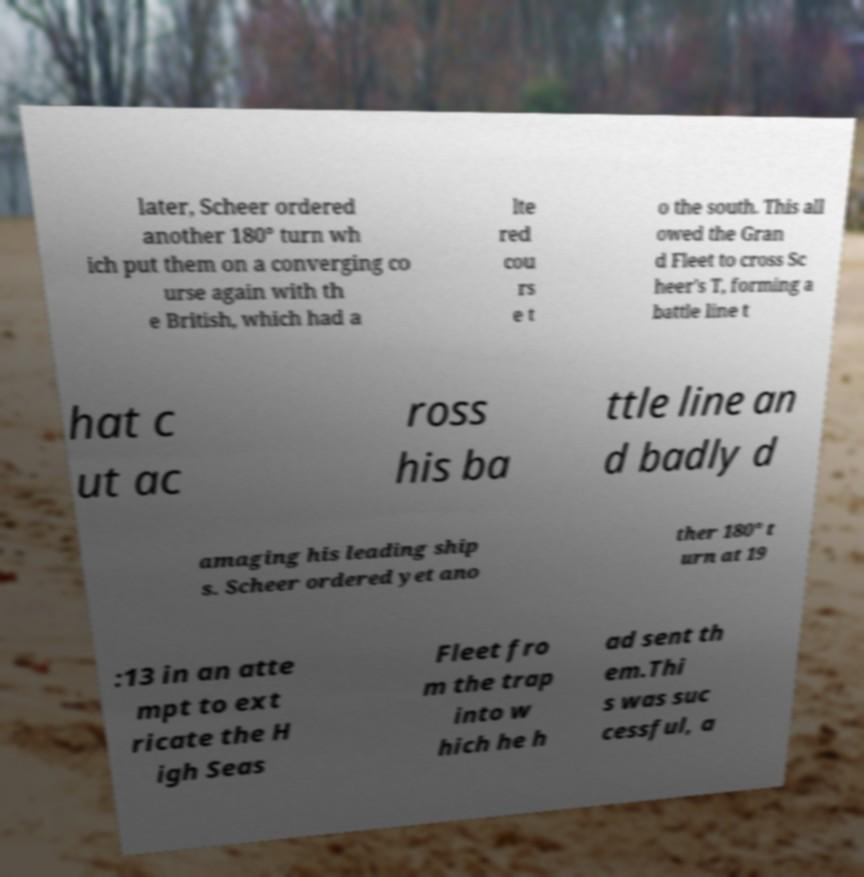Could you assist in decoding the text presented in this image and type it out clearly? later, Scheer ordered another 180° turn wh ich put them on a converging co urse again with th e British, which had a lte red cou rs e t o the south. This all owed the Gran d Fleet to cross Sc heer's T, forming a battle line t hat c ut ac ross his ba ttle line an d badly d amaging his leading ship s. Scheer ordered yet ano ther 180° t urn at 19 :13 in an atte mpt to ext ricate the H igh Seas Fleet fro m the trap into w hich he h ad sent th em.Thi s was suc cessful, a 